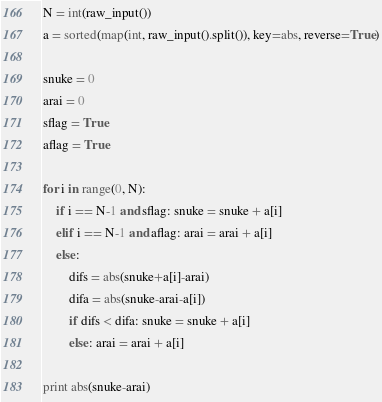Convert code to text. <code><loc_0><loc_0><loc_500><loc_500><_Python_>N = int(raw_input())
a = sorted(map(int, raw_input().split()), key=abs, reverse=True)

snuke = 0
arai = 0
sflag = True
aflag = True

for i in range(0, N):
	if i == N-1 and sflag: snuke = snuke + a[i]
	elif i == N-1 and aflag: arai = arai + a[i]
	else:
		difs = abs(snuke+a[i]-arai)
		difa = abs(snuke-arai-a[i])
		if difs < difa: snuke = snuke + a[i]
		else: arai = arai + a[i]

print abs(snuke-arai)</code> 